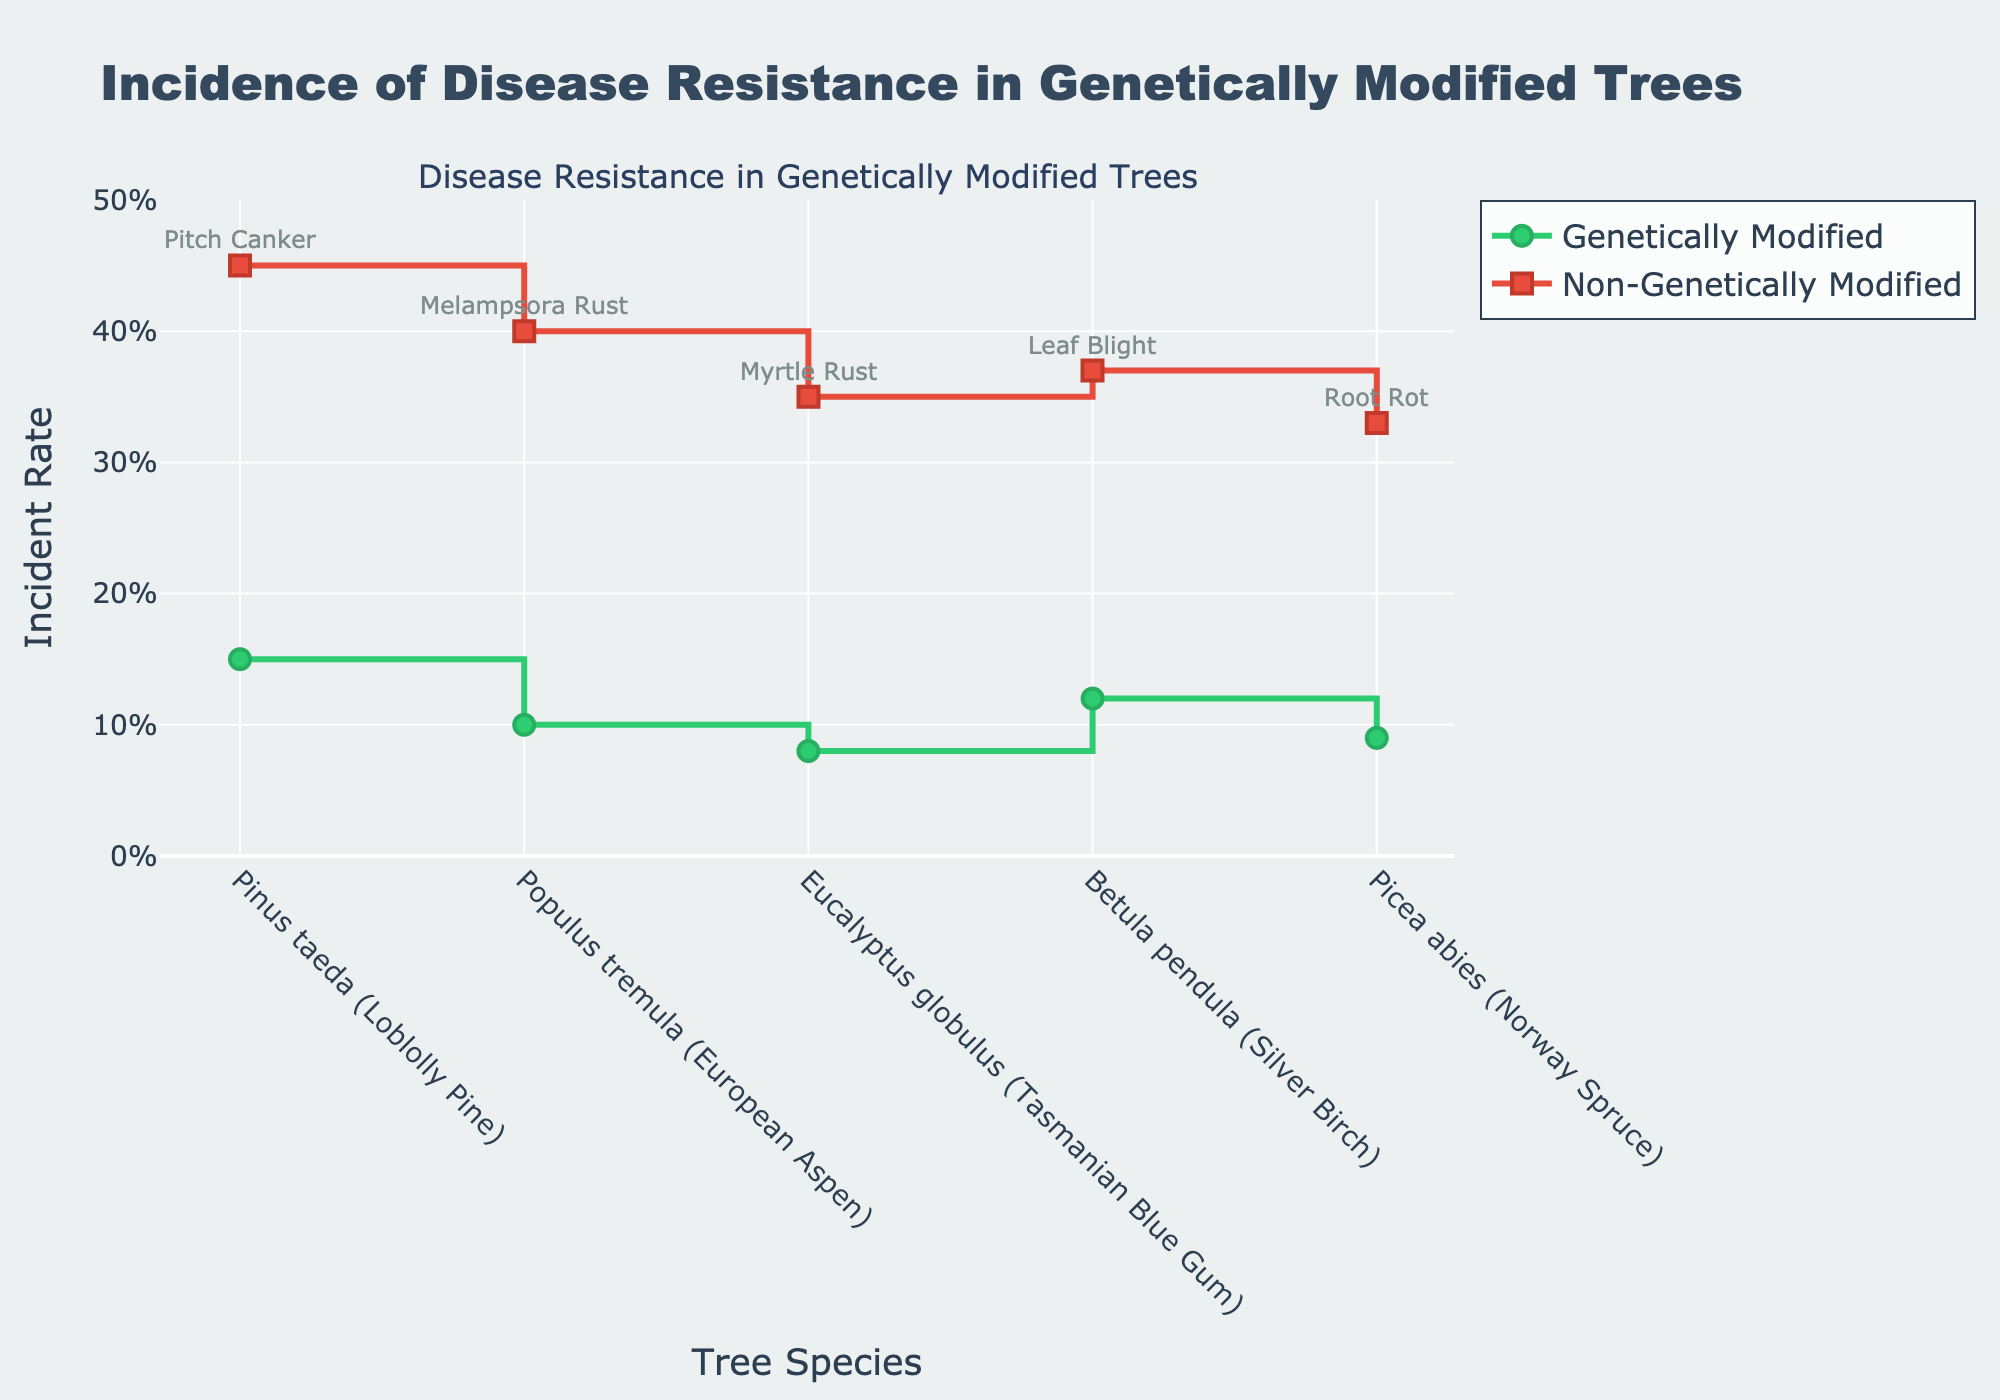What is the title of the figure? The figure's title is usually displayed at the top center. It can be read directly from the figure.
Answer: Incidence of Disease Resistance in Genetically Modified Trees Which species has the highest incident rate for genetically modified trees? By looking at the green line (Genetically Modified), we can identify the species with the highest point on the y-axis.
Answer: Pinus taeda (Loblolly Pine) What is the incident rate of disease resistance for non-genetically modified European Aspen trees? Locate the red line (Non-Genetically Modified) corresponding to European Aspen on the x-axis and note the y-axis value.
Answer: 0.40 How many species of trees are included in the figure? Count the number of distinct categories on the x-axis.
Answer: 5 Which species shows the greatest difference in incident rates between genetically modified and non-genetically modified trees? Calculate the absolute difference in incident rates between GM and non-GM for each species and identify the one with the largest value.
Answer: Pinus taeda (Loblolly Pine) What is the average incident rate of disease resistance for genetically modified trees across all species? Sum the incident rates for genetically modified trees and divide by the number of species (0.15 + 0.10 + 0.08 + 0.12 + 0.09) / 5.
Answer: 0.108 Is there any species in which genetically modified trees do not perform better in disease resistance than non-genetically modified trees? Compare the incident rates of genetically modified and non-genetically modified trees for each species to see if all GM trees have lower incident rates.
Answer: No Which disease affects the genetically modified Silver Birch trees as shown in the annotations? Identify the annotation near the incident rate point for Silver Birch.
Answer: Leaf Blight What is the range of the y-axis in the figure? Observe the minimum and maximum values on the y-axis.
Answer: 0 to 0.5 Which color represents genetically modified trees on the plot? Refer to the color of the line associated with genetically modified trees.
Answer: Green 